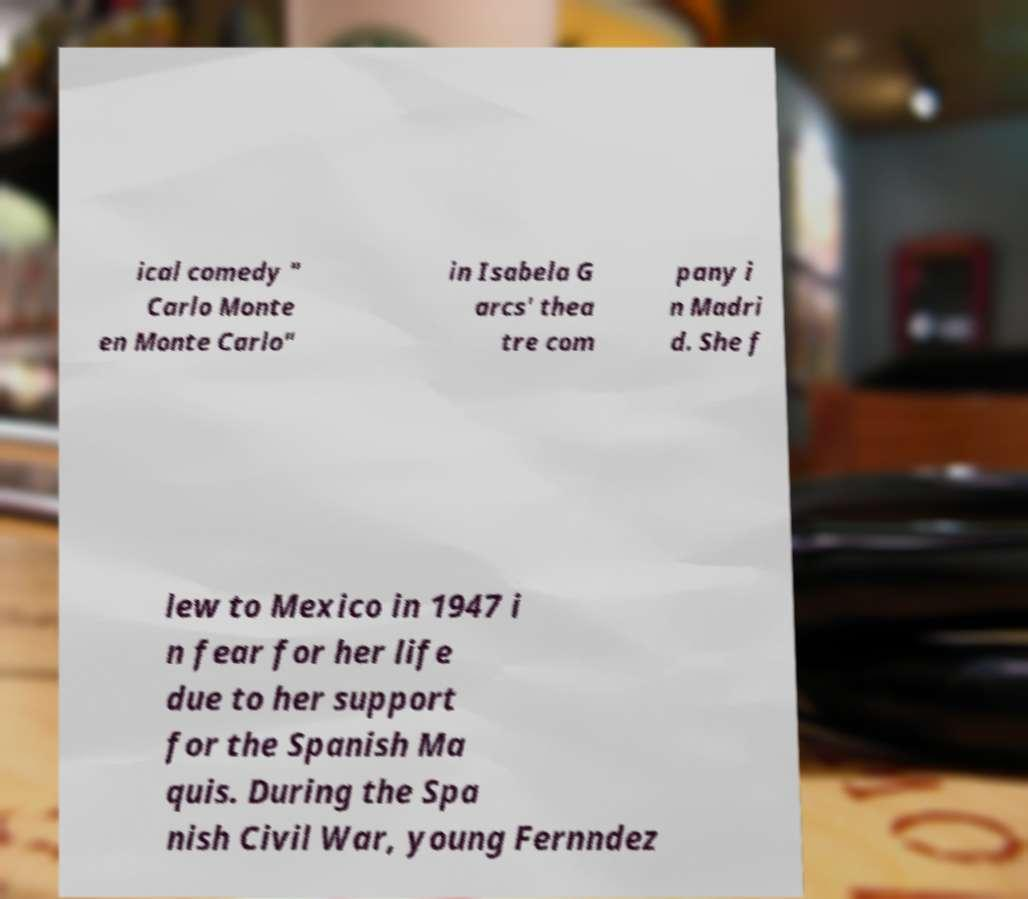What messages or text are displayed in this image? I need them in a readable, typed format. ical comedy " Carlo Monte en Monte Carlo" in Isabela G arcs' thea tre com pany i n Madri d. She f lew to Mexico in 1947 i n fear for her life due to her support for the Spanish Ma quis. During the Spa nish Civil War, young Fernndez 